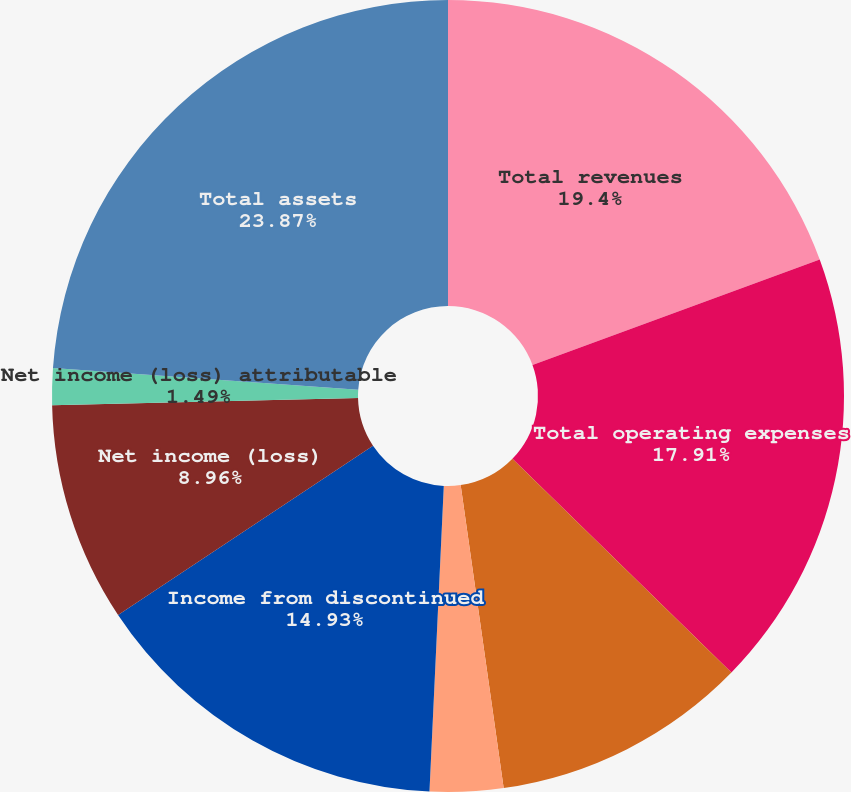<chart> <loc_0><loc_0><loc_500><loc_500><pie_chart><fcel>Total revenues<fcel>Total operating expenses<fcel>Operating income<fcel>Income (loss) from continuing<fcel>Income from discontinued<fcel>Net income (loss)<fcel>Net income (loss) attributable<fcel>Total assets<nl><fcel>19.4%<fcel>17.91%<fcel>10.45%<fcel>2.99%<fcel>14.93%<fcel>8.96%<fcel>1.49%<fcel>23.88%<nl></chart> 